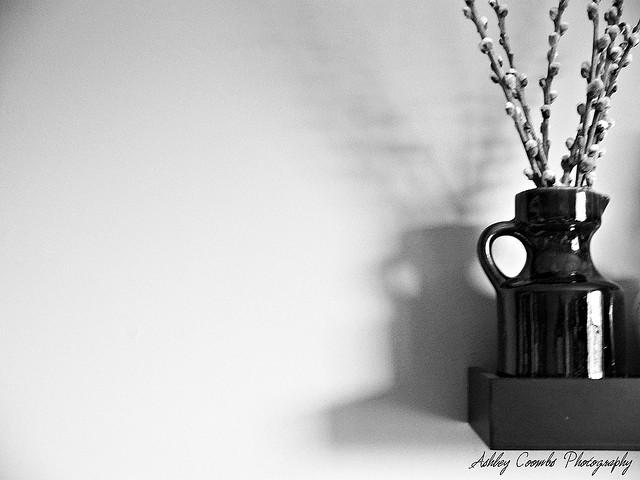Who took this picture?
Write a very short answer. Ashley combs. Is there a watermark in this picture?
Concise answer only. Yes. How many flower sticks are there in the pot?
Be succinct. 6. 